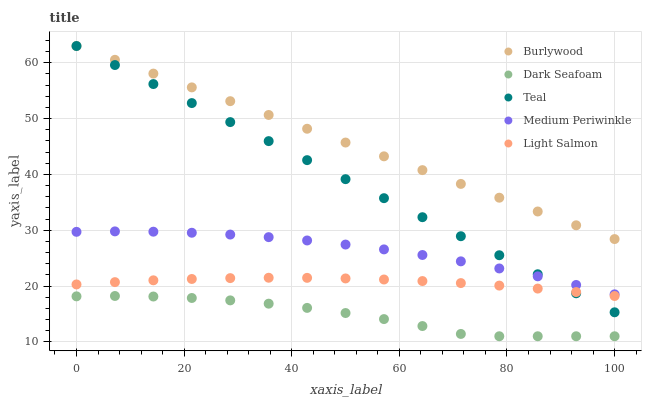Does Dark Seafoam have the minimum area under the curve?
Answer yes or no. Yes. Does Burlywood have the maximum area under the curve?
Answer yes or no. Yes. Does Medium Periwinkle have the minimum area under the curve?
Answer yes or no. No. Does Medium Periwinkle have the maximum area under the curve?
Answer yes or no. No. Is Teal the smoothest?
Answer yes or no. Yes. Is Dark Seafoam the roughest?
Answer yes or no. Yes. Is Medium Periwinkle the smoothest?
Answer yes or no. No. Is Medium Periwinkle the roughest?
Answer yes or no. No. Does Dark Seafoam have the lowest value?
Answer yes or no. Yes. Does Medium Periwinkle have the lowest value?
Answer yes or no. No. Does Teal have the highest value?
Answer yes or no. Yes. Does Medium Periwinkle have the highest value?
Answer yes or no. No. Is Light Salmon less than Medium Periwinkle?
Answer yes or no. Yes. Is Medium Periwinkle greater than Dark Seafoam?
Answer yes or no. Yes. Does Medium Periwinkle intersect Teal?
Answer yes or no. Yes. Is Medium Periwinkle less than Teal?
Answer yes or no. No. Is Medium Periwinkle greater than Teal?
Answer yes or no. No. Does Light Salmon intersect Medium Periwinkle?
Answer yes or no. No. 